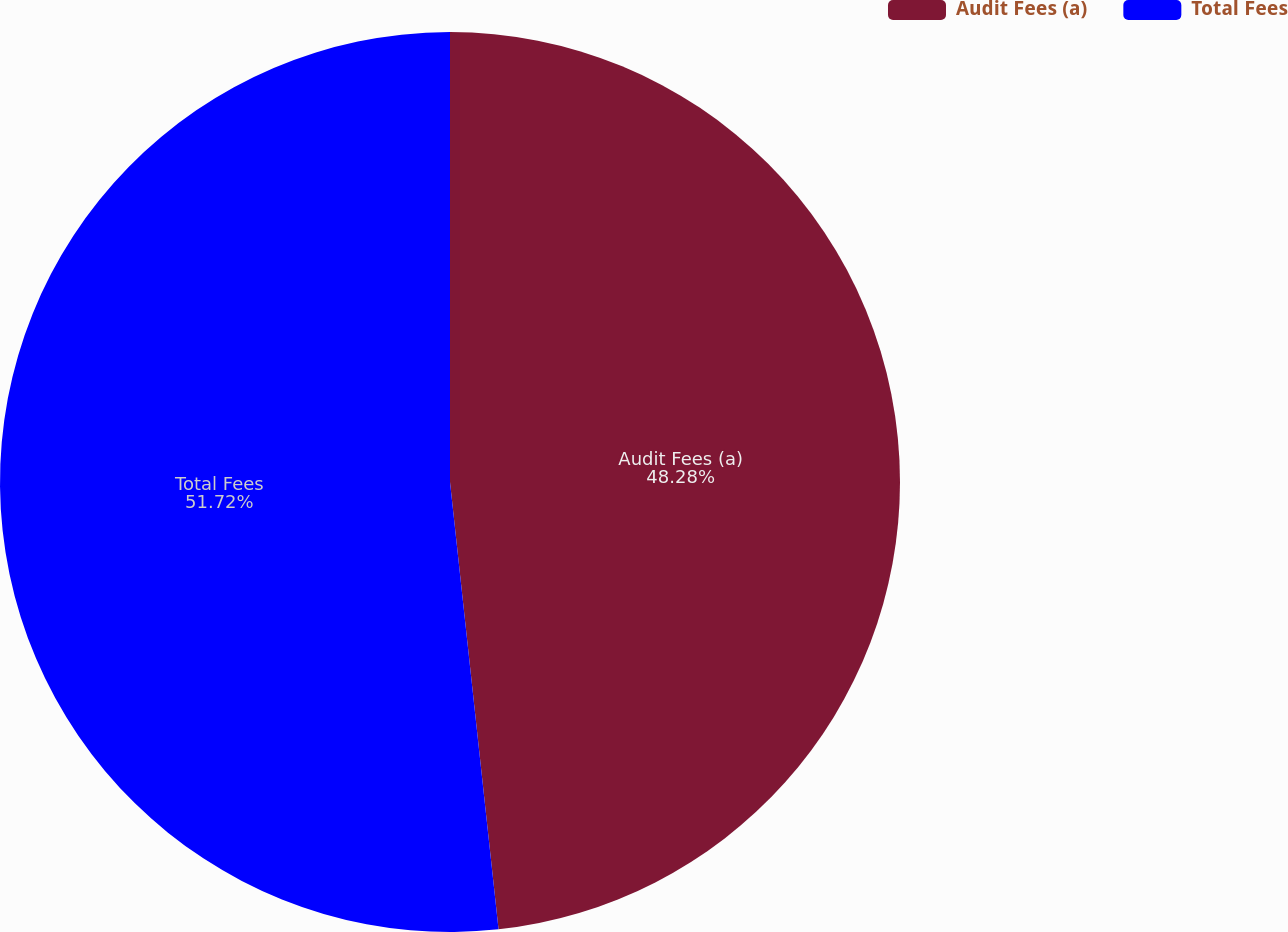Convert chart to OTSL. <chart><loc_0><loc_0><loc_500><loc_500><pie_chart><fcel>Audit Fees (a)<fcel>Total Fees<nl><fcel>48.28%<fcel>51.72%<nl></chart> 